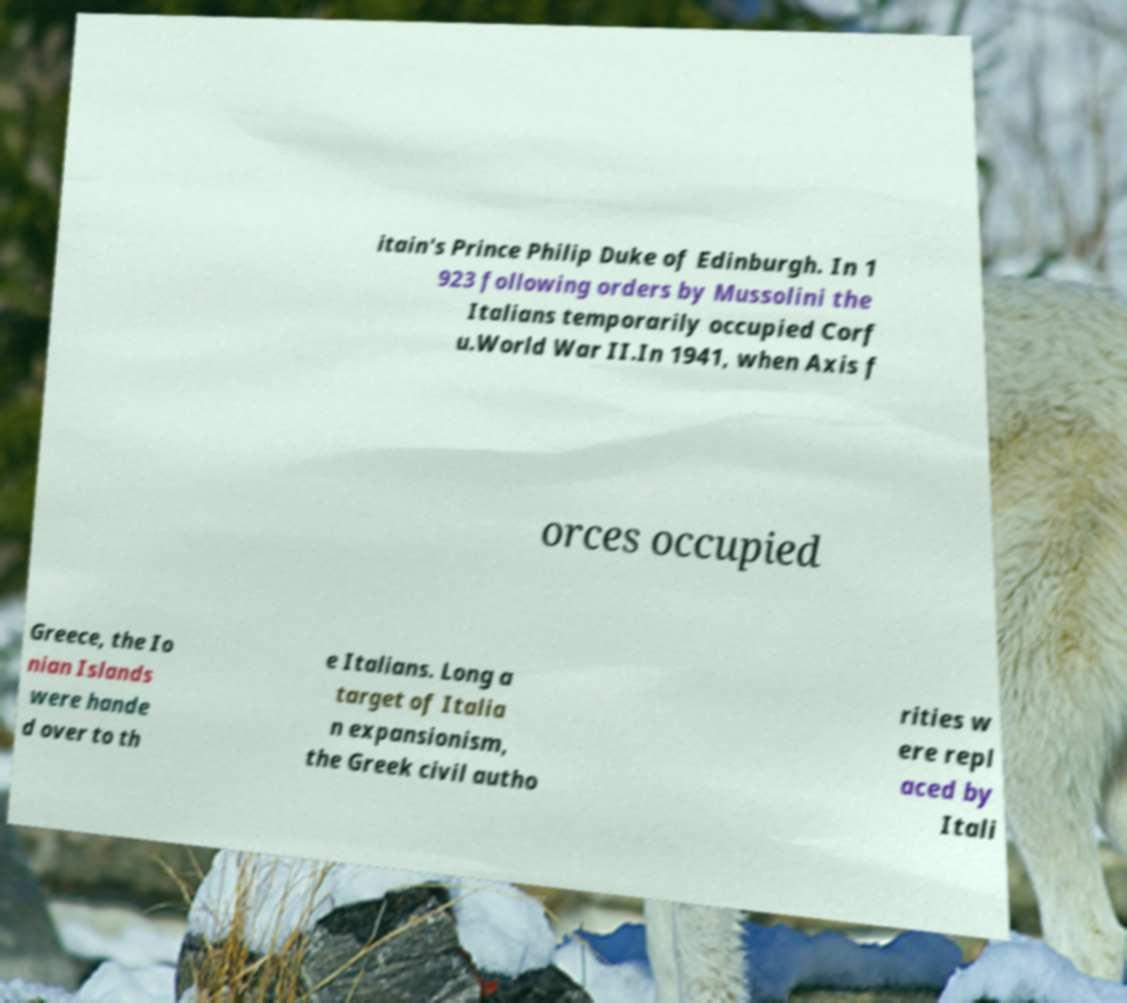Can you accurately transcribe the text from the provided image for me? itain's Prince Philip Duke of Edinburgh. In 1 923 following orders by Mussolini the Italians temporarily occupied Corf u.World War II.In 1941, when Axis f orces occupied Greece, the Io nian Islands were hande d over to th e Italians. Long a target of Italia n expansionism, the Greek civil autho rities w ere repl aced by Itali 